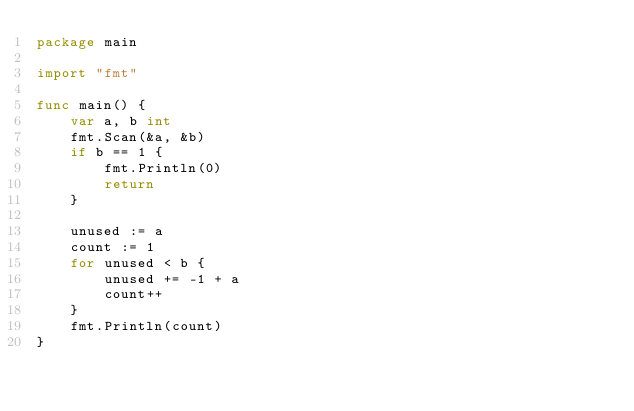Convert code to text. <code><loc_0><loc_0><loc_500><loc_500><_Go_>package main

import "fmt"

func main() {
	var a, b int
	fmt.Scan(&a, &b)
	if b == 1 {
		fmt.Println(0)
		return
	}

	unused := a
	count := 1
	for unused < b {
		unused += -1 + a
		count++
	}
	fmt.Println(count)
}
</code> 